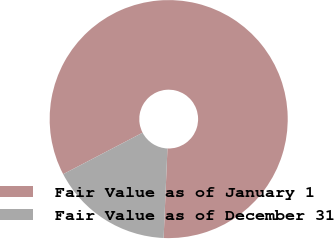<chart> <loc_0><loc_0><loc_500><loc_500><pie_chart><fcel>Fair Value as of January 1<fcel>Fair Value as of December 31<nl><fcel>83.33%<fcel>16.67%<nl></chart> 